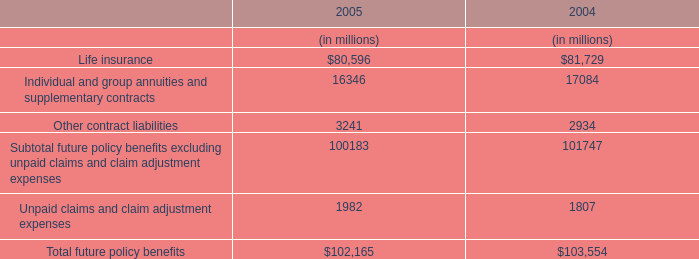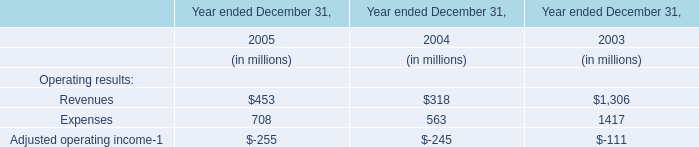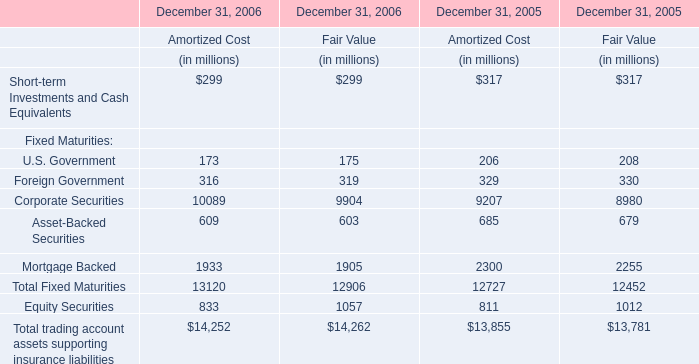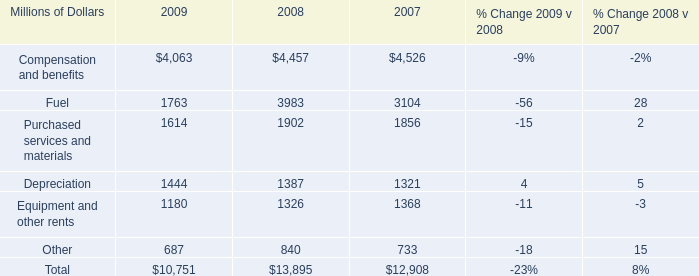What is the sum of the Asset-Backed Securities in the years where U.S. Government for Amortized Cost greater than 200? (in million) 
Computations: (685 + 679)
Answer: 1364.0. 